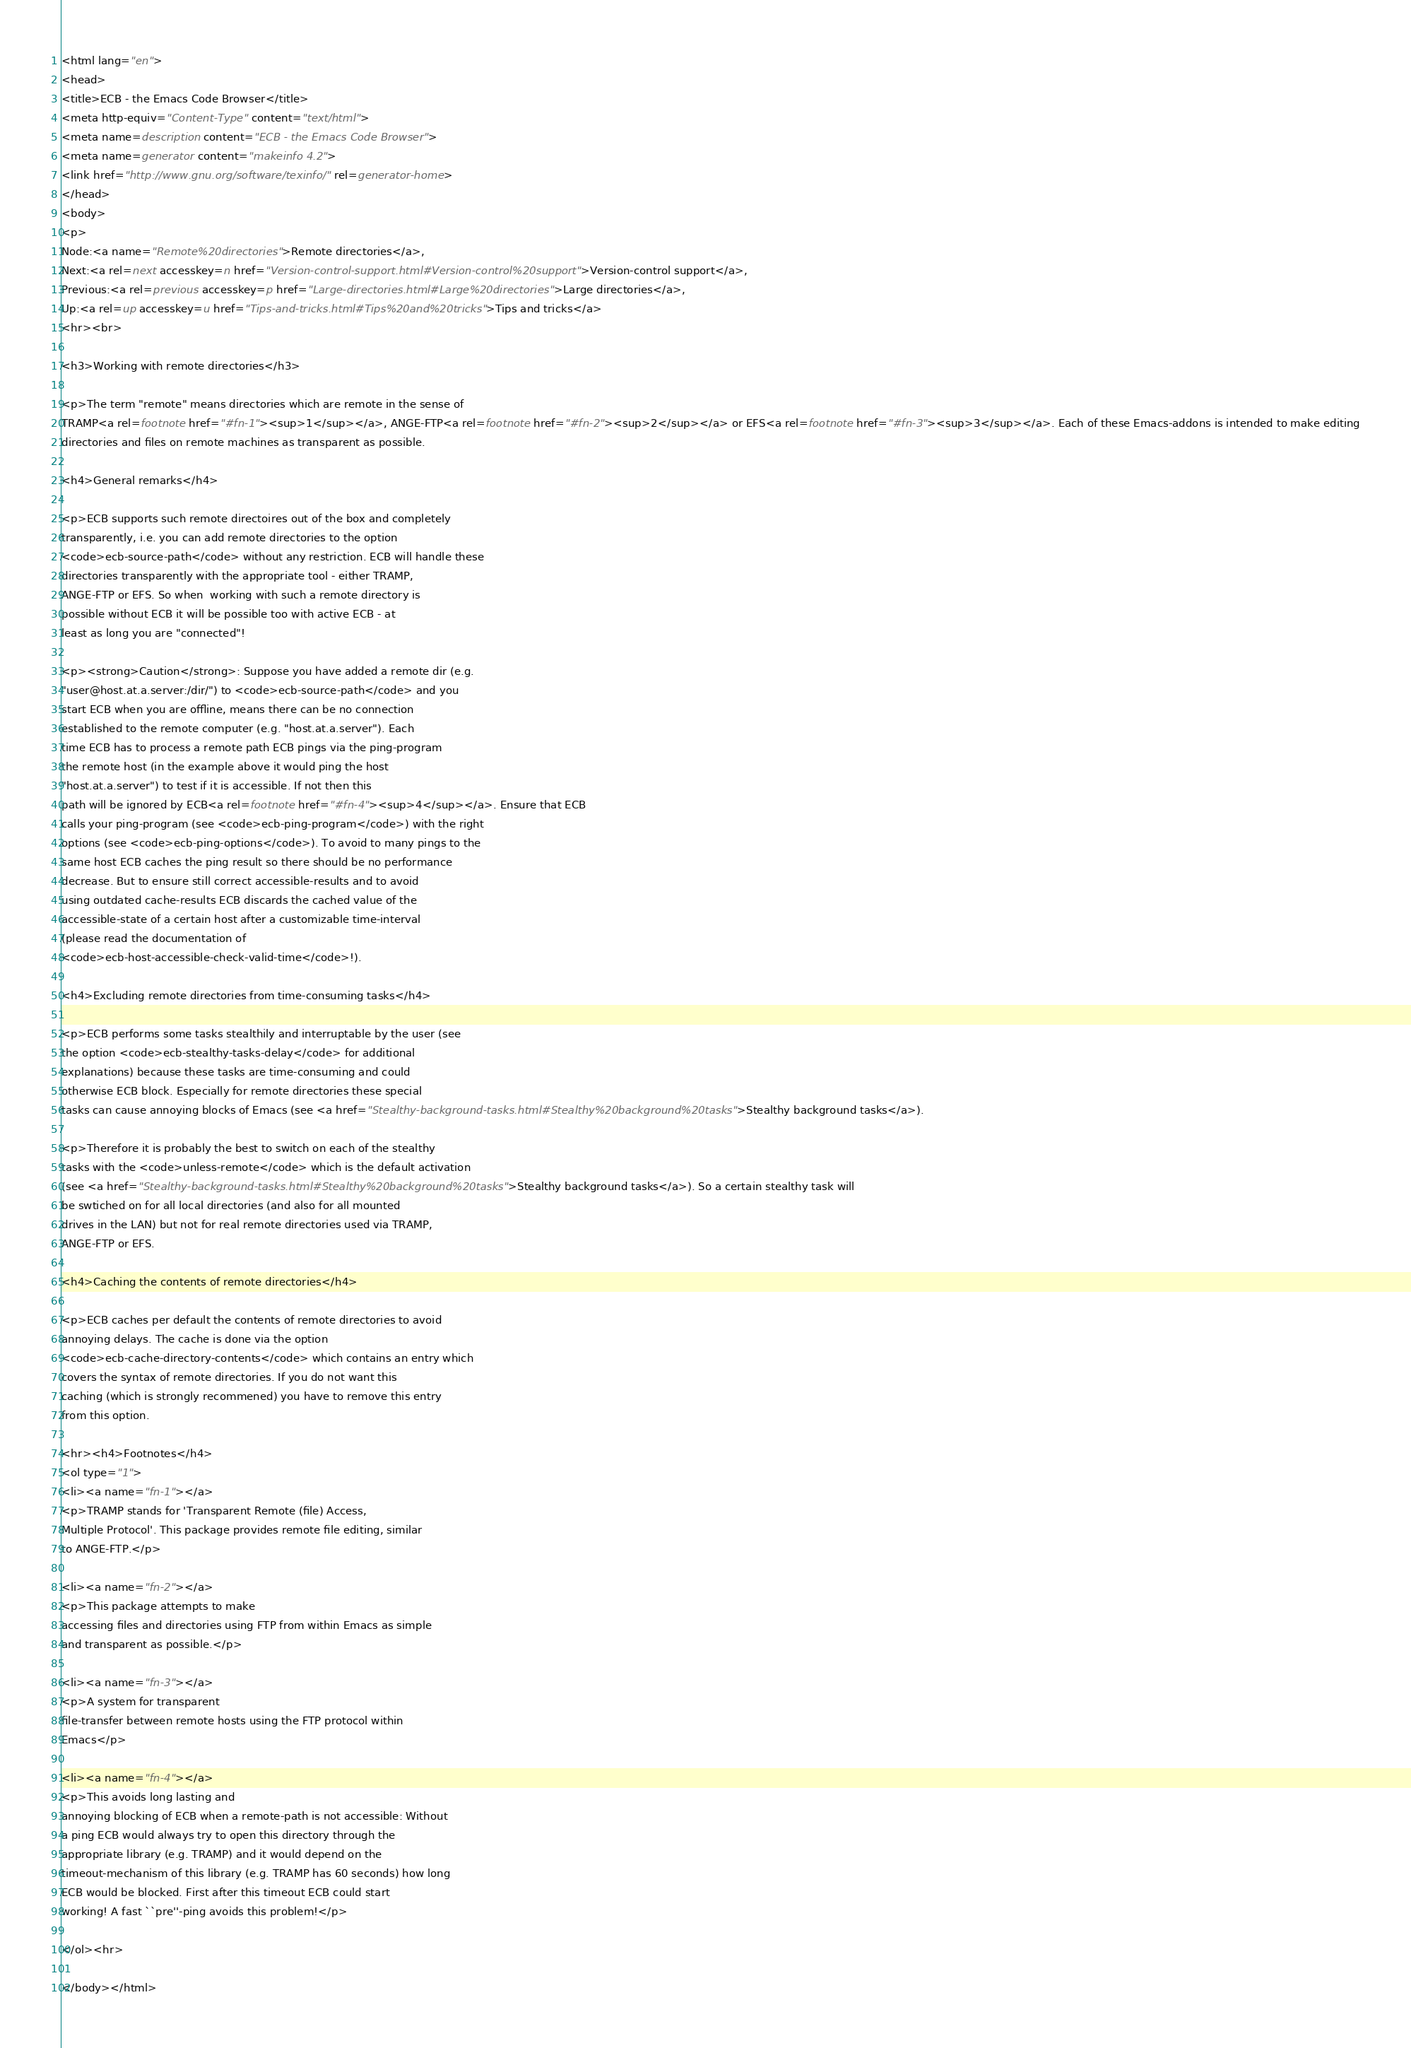<code> <loc_0><loc_0><loc_500><loc_500><_HTML_><html lang="en">
<head>
<title>ECB - the Emacs Code Browser</title>
<meta http-equiv="Content-Type" content="text/html">
<meta name=description content="ECB - the Emacs Code Browser">
<meta name=generator content="makeinfo 4.2">
<link href="http://www.gnu.org/software/texinfo/" rel=generator-home>
</head>
<body>
<p>
Node:<a name="Remote%20directories">Remote directories</a>,
Next:<a rel=next accesskey=n href="Version-control-support.html#Version-control%20support">Version-control support</a>,
Previous:<a rel=previous accesskey=p href="Large-directories.html#Large%20directories">Large directories</a>,
Up:<a rel=up accesskey=u href="Tips-and-tricks.html#Tips%20and%20tricks">Tips and tricks</a>
<hr><br>

<h3>Working with remote directories</h3>

<p>The term "remote" means directories which are remote in the sense of
TRAMP<a rel=footnote href="#fn-1"><sup>1</sup></a>, ANGE-FTP<a rel=footnote href="#fn-2"><sup>2</sup></a> or EFS<a rel=footnote href="#fn-3"><sup>3</sup></a>. Each of these Emacs-addons is intended to make editing
directories and files on remote machines as transparent as possible.

<h4>General remarks</h4>

<p>ECB supports such remote directoires out of the box and completely
transparently, i.e. you can add remote directories to the option
<code>ecb-source-path</code> without any restriction. ECB will handle these
directories transparently with the appropriate tool - either TRAMP,
ANGE-FTP or EFS. So when  working with such a remote directory is
possible without ECB it will be possible too with active ECB - at
least as long you are "connected"!

<p><strong>Caution</strong>: Suppose you have added a remote dir (e.g. 
"user@host.at.a.server:/dir/") to <code>ecb-source-path</code> and you
start ECB when you are offline, means there can be no connection
established to the remote computer (e.g. "host.at.a.server"). Each
time ECB has to process a remote path ECB pings via the ping-program
the remote host (in the example above it would ping the host
"host.at.a.server") to test if it is accessible. If not then this
path will be ignored by ECB<a rel=footnote href="#fn-4"><sup>4</sup></a>. Ensure that ECB
calls your ping-program (see <code>ecb-ping-program</code>) with the right
options (see <code>ecb-ping-options</code>). To avoid to many pings to the
same host ECB caches the ping result so there should be no performance
decrease. But to ensure still correct accessible-results and to avoid
using outdated cache-results ECB discards the cached value of the
accessible-state of a certain host after a customizable time-interval
(please read the documentation of
<code>ecb-host-accessible-check-valid-time</code>!).

<h4>Excluding remote directories from time-consuming tasks</h4>

<p>ECB performs some tasks stealthily and interruptable by the user (see
the option <code>ecb-stealthy-tasks-delay</code> for additional
explanations) because these tasks are time-consuming and could
otherwise ECB block. Especially for remote directories these special
tasks can cause annoying blocks of Emacs (see <a href="Stealthy-background-tasks.html#Stealthy%20background%20tasks">Stealthy background tasks</a>).

<p>Therefore it is probably the best to switch on each of the stealthy
tasks with the <code>unless-remote</code> which is the default activation
(see <a href="Stealthy-background-tasks.html#Stealthy%20background%20tasks">Stealthy background tasks</a>). So a certain stealthy task will
be swtiched on for all local directories (and also for all mounted
drives in the LAN) but not for real remote directories used via TRAMP,
ANGE-FTP or EFS.

<h4>Caching the contents of remote directories</h4>

<p>ECB caches per default the contents of remote directories to avoid
annoying delays. The cache is done via the option
<code>ecb-cache-directory-contents</code> which contains an entry which
covers the syntax of remote directories. If you do not want this
caching (which is strongly recommened) you have to remove this entry
from this option.

<hr><h4>Footnotes</h4>
<ol type="1">
<li><a name="fn-1"></a>
<p>TRAMP stands for 'Transparent Remote (file) Access,
Multiple Protocol'. This package provides remote file editing, similar
to ANGE-FTP.</p>

<li><a name="fn-2"></a>
<p>This package attempts to make
accessing files and directories using FTP from within Emacs as simple
and transparent as possible.</p>

<li><a name="fn-3"></a>
<p>A system for transparent
file-transfer between remote hosts using the FTP protocol within
Emacs</p>

<li><a name="fn-4"></a>
<p>This avoids long lasting and
annoying blocking of ECB when a remote-path is not accessible: Without
a ping ECB would always try to open this directory through the
appropriate library (e.g. TRAMP) and it would depend on the
timeout-mechanism of this library (e.g. TRAMP has 60 seconds) how long
ECB would be blocked. First after this timeout ECB could start
working! A fast ``pre''-ping avoids this problem!</p>

</ol><hr>

</body></html>

</code> 